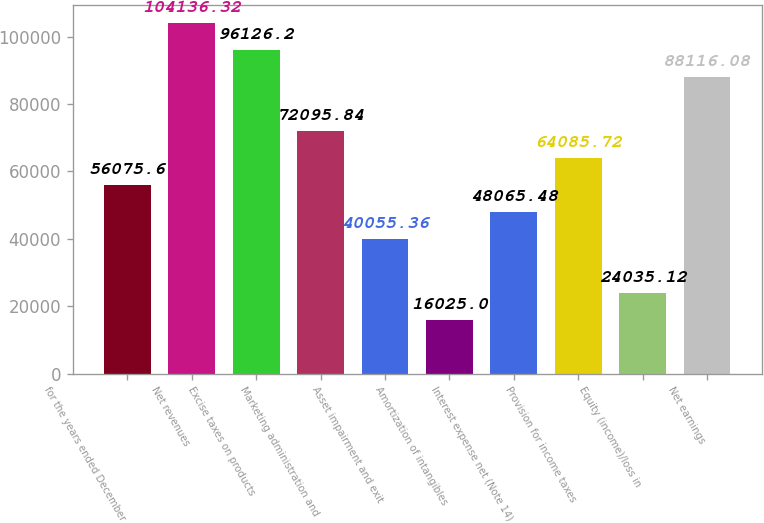Convert chart to OTSL. <chart><loc_0><loc_0><loc_500><loc_500><bar_chart><fcel>for the years ended December<fcel>Net revenues<fcel>Excise taxes on products<fcel>Marketing administration and<fcel>Asset impairment and exit<fcel>Amortization of intangibles<fcel>Interest expense net (Note 14)<fcel>Provision for income taxes<fcel>Equity (income)/loss in<fcel>Net earnings<nl><fcel>56075.6<fcel>104136<fcel>96126.2<fcel>72095.8<fcel>40055.4<fcel>16025<fcel>48065.5<fcel>64085.7<fcel>24035.1<fcel>88116.1<nl></chart> 